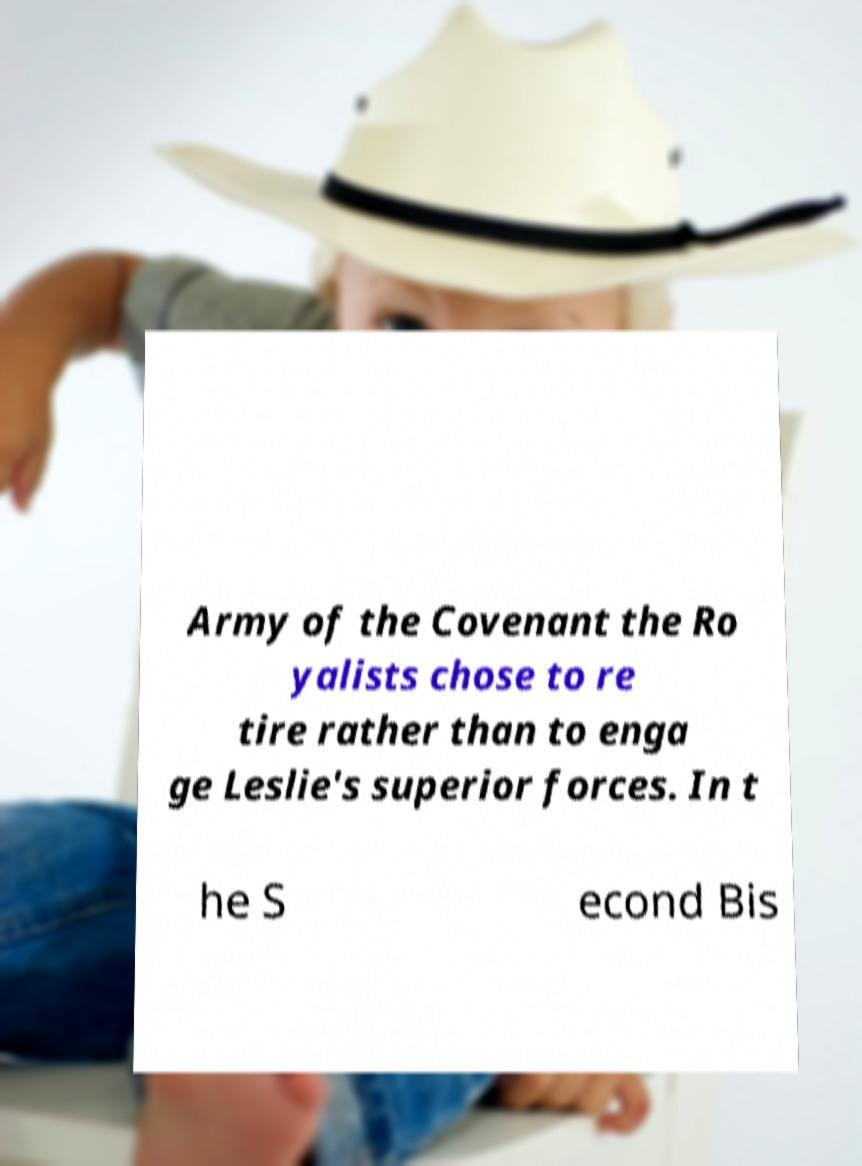Can you accurately transcribe the text from the provided image for me? Army of the Covenant the Ro yalists chose to re tire rather than to enga ge Leslie's superior forces. In t he S econd Bis 